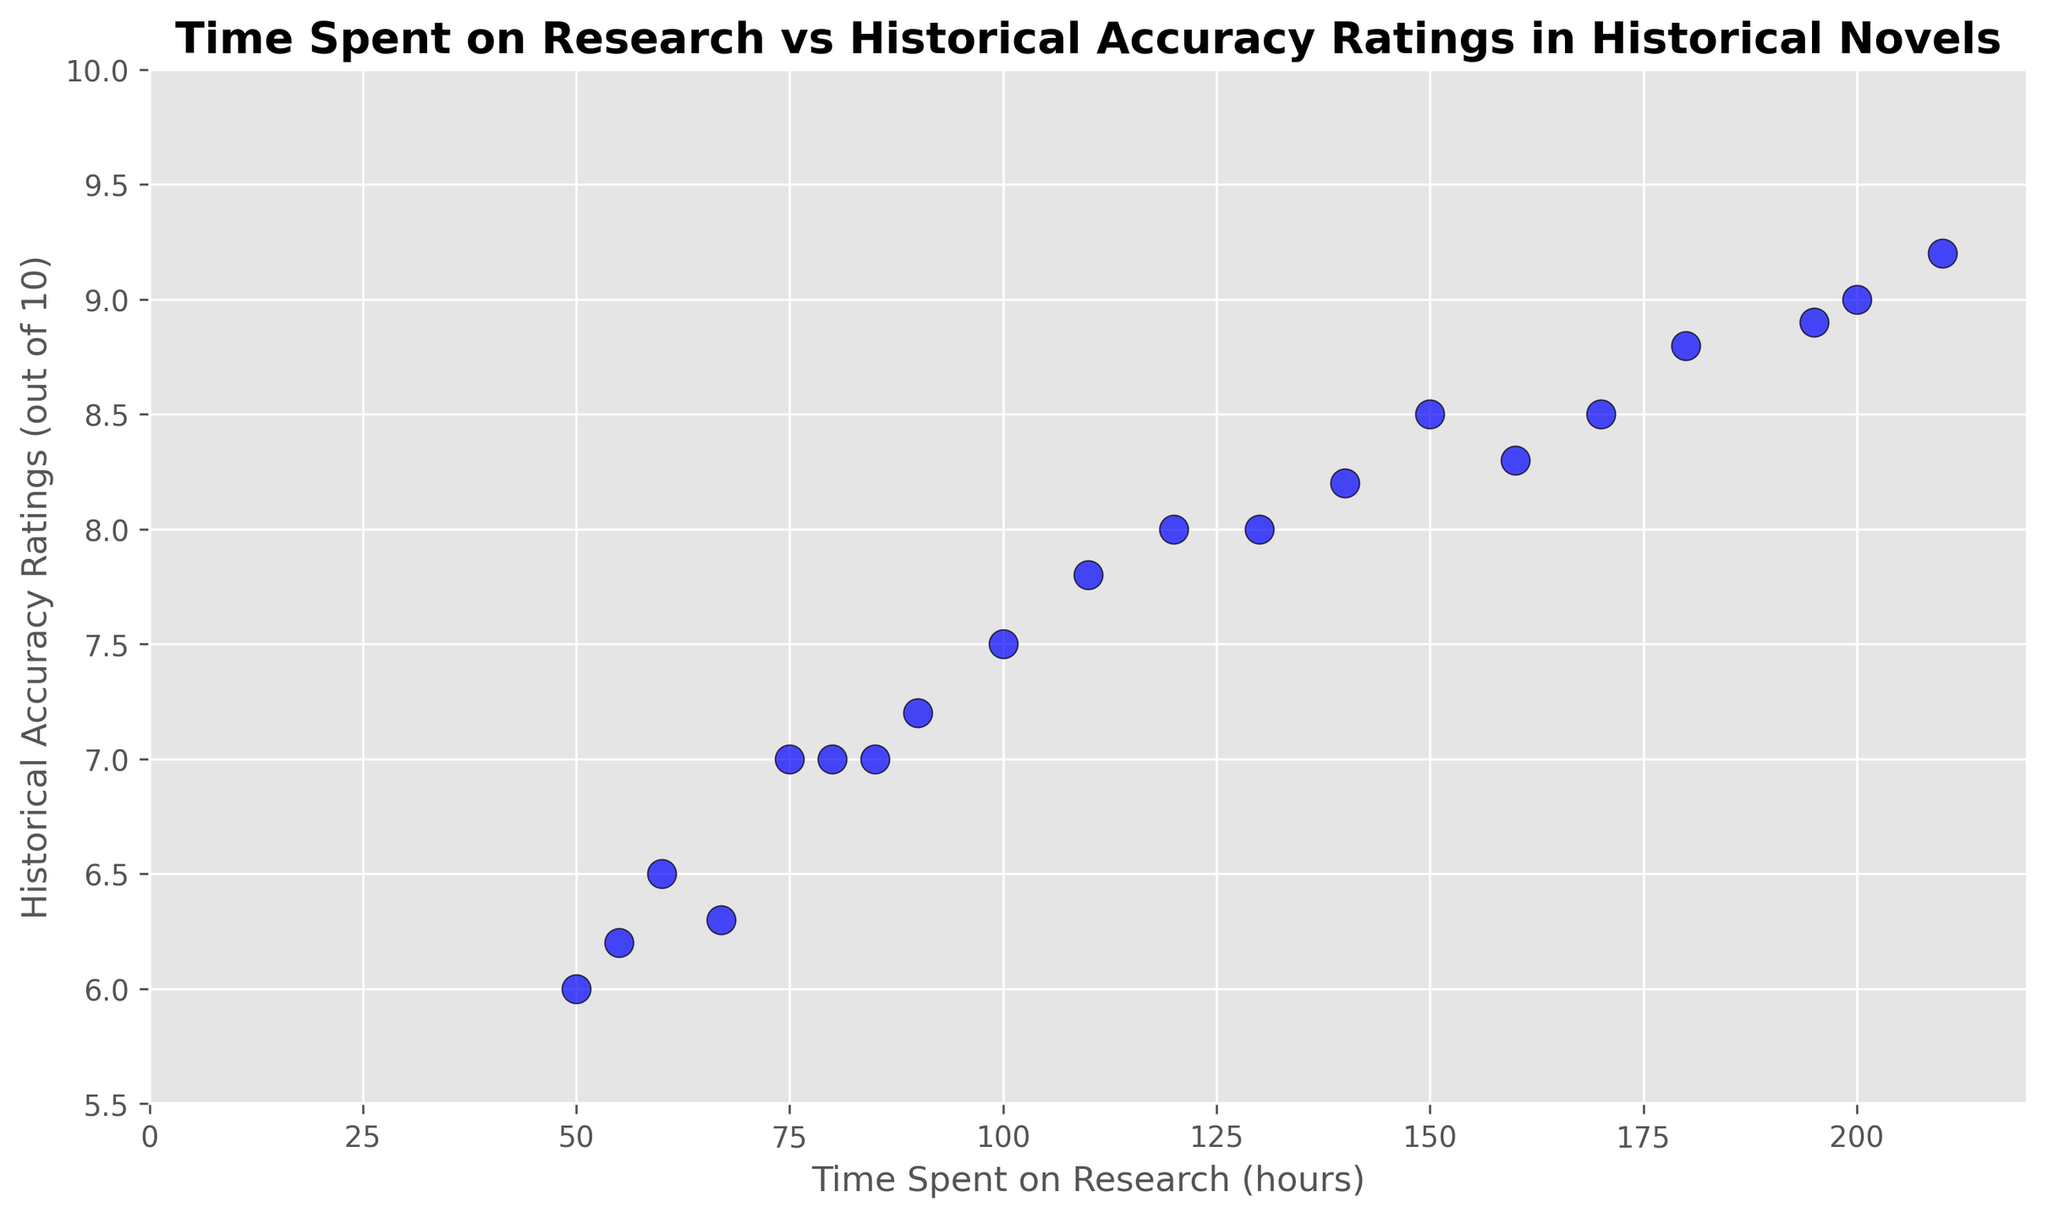What is the general trend in the relationship between time spent on research and historical accuracy ratings? Most of the points show a positive correlation, meaning as the time spent on research increases, the historical accuracy ratings tend to increase as well.
Answer: Positive correlation What's the historical accuracy rating for the novel with the most time spent on research? The novel with the most time spent on research is at 210 hours, which corresponds to a historical accuracy rating of 9.2.
Answer: 9.2 How many novels spent more than 150 hours on research and have an accuracy rating above 8? We need to count the number of points that are both above 150 on the x-axis and above 8 on the y-axis. Those points correspond to (195,8.9), (210,9.2), (180,8.8), (170,8.5), (160,8.3). So, there are 5 such novels.
Answer: 5 What is the average historical accuracy rating of novels that spent 100 to 150 hours on research? Identify the points within the range of 100 to 150 hours on the x-axis: (100,7.5), (110,7.8), (130,8), (140,8.2), (150,8.5). Their ratings are 7.5, 7.8, 8, 8.2, 8.5. The average is (7.5 + 7.8 + 8 + 8.2 + 8.5) / 5 = 8
Answer: 8 Which novel spent the least time on research but still achieved an accuracy rating of 8 or above? Identify the points where the y-value (accuracy rating) is 8 or above and find the minimum x-value (time spent). The point (120,8) is the lowest time spent which achieved an accuracy rating of 8.
Answer: 120 hours What is the range of historical accuracy ratings for novels that spent between 50 and 90 hours on research? Identify the points within the range of 50 to 90 hours on the x-axis: (50,6), (60,6.5), (75,7), (80,7), (90,7.2), (85,7), (67,6.3), (55,6.2). Their ratings are 6, 6.5, 7, 7, 7.2, 7, 6.3, 6.2. The range is 7.2 - 6 = 1.2
Answer: 1.2 Is there any novel that has a historical accuracy rating higher than 9? Check the y-axis values and identify if any point is above 9. The point (210,9.2) has a historical accuracy rating higher than 9.
Answer: Yes What is the difference in historical accuracy ratings between the novels that spent 55 hours and 67 hours on research? The points corresponding to 55 hours and 67 hours are (55,6.2) and (67,6.3), respectively. The difference is 6.3 - 6.2 = 0.1
Answer: 0.1 Which novel that spent less than 100 hours on research has the highest historical accuracy rating? Identify the points with x-values less than 100 and find the maximum y-value. The point (90,7.2) has the highest rating among those which spent less than 100 hours.
Answer: 7.2 